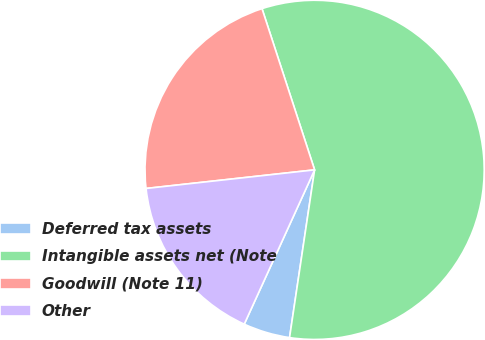<chart> <loc_0><loc_0><loc_500><loc_500><pie_chart><fcel>Deferred tax assets<fcel>Intangible assets net (Note<fcel>Goodwill (Note 11)<fcel>Other<nl><fcel>4.45%<fcel>57.38%<fcel>21.73%<fcel>16.44%<nl></chart> 